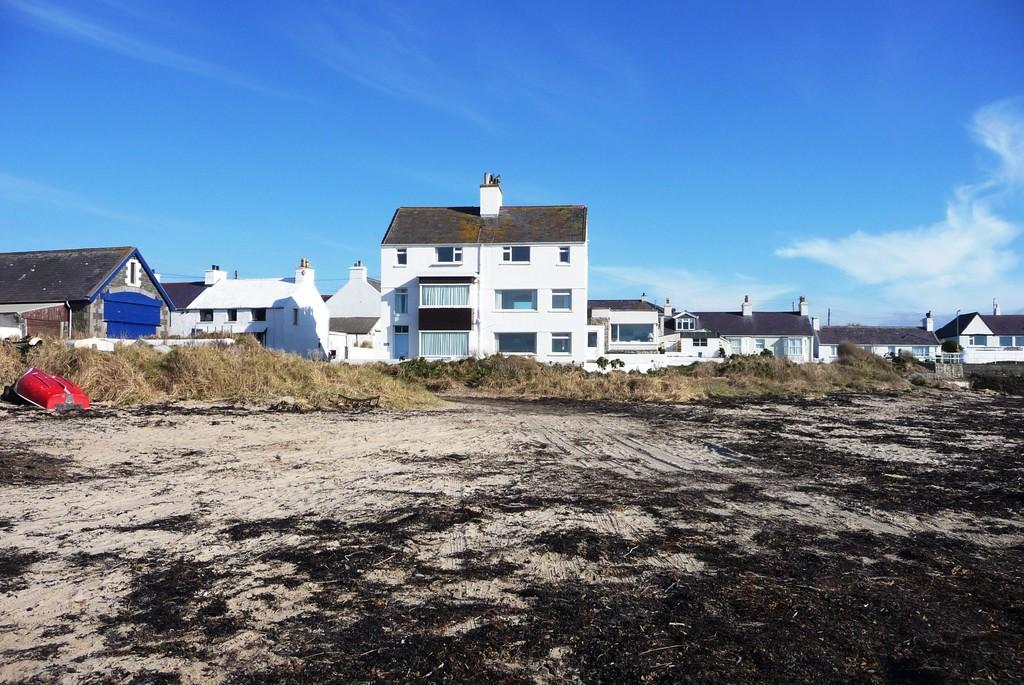Please provide a concise description of this image. In this image I can see some object in red color, the dried grass, few buildings in brown and white color and the sky is in blue and white color. 